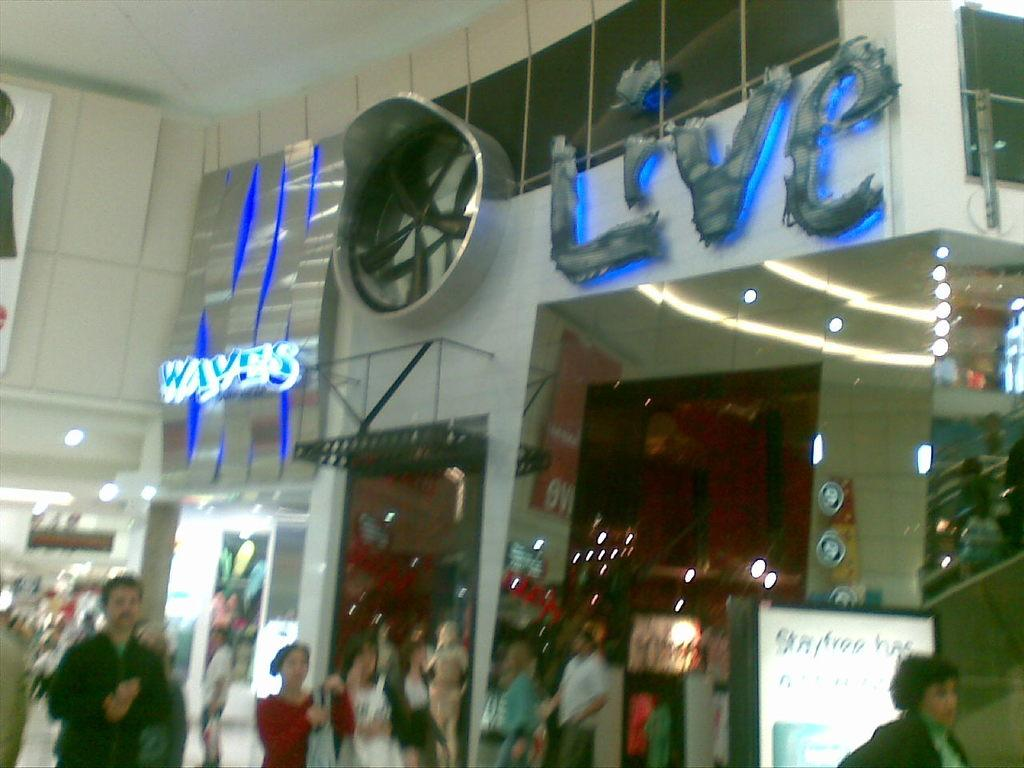Where was the image taken? The image is taken inside a building. What can be seen at the bottom of the image? People are walking at the bottom of the image. What type of objects are visible in the image? There are boards visible in the image. What type of establishment can be seen in the image? There are stores in the image. What type of cave can be seen in the image? There is no cave present in the image; it is taken inside a building with stores and people walking. What brand of soap is being advertised on the boards in the image? There is no soap or advertisement visible on the boards in the image. 